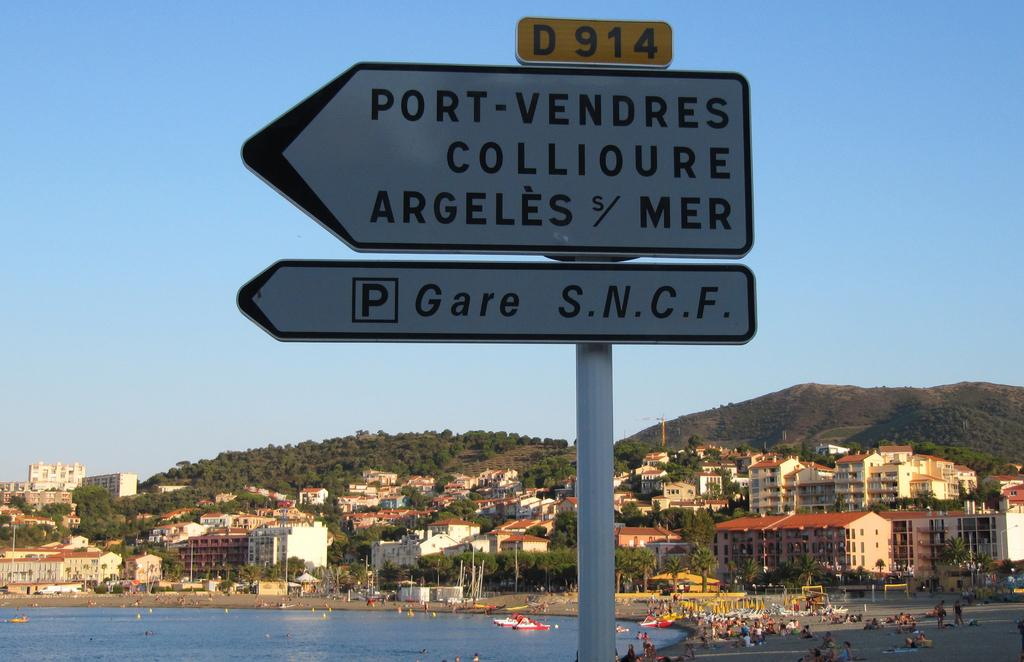<image>
Present a compact description of the photo's key features. A Port-Vendres sign in front of a coastal town and a blue sky. 